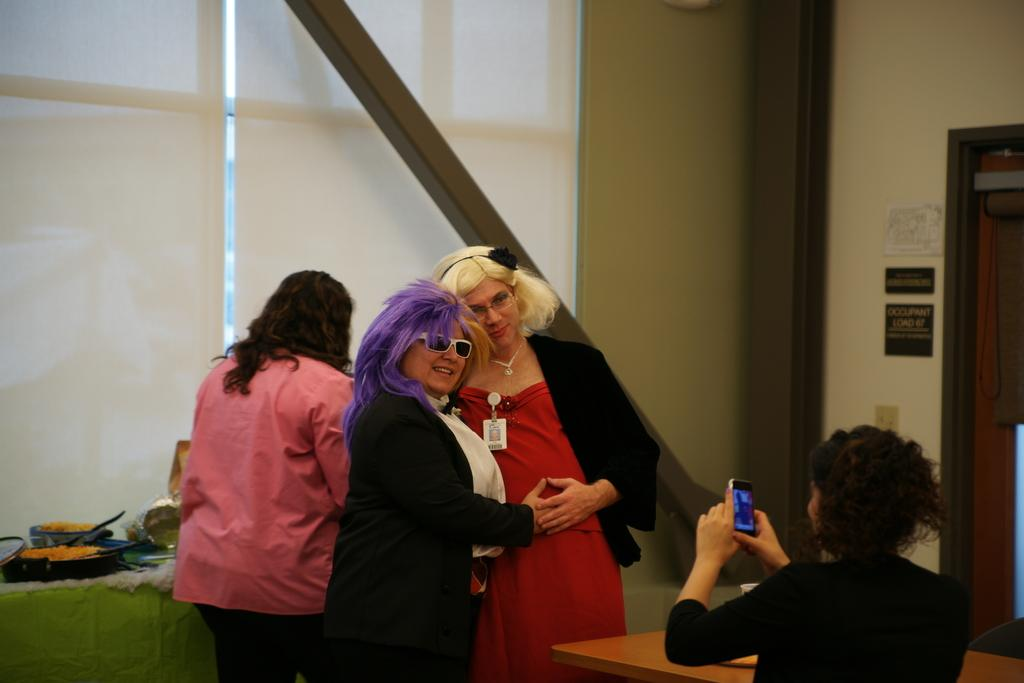What can be seen in the image? There are women standing in the image. Where are the women standing? The women are standing on the floor. What can be seen in the background of the image? There are cooking pans, doors, name plates, a switch board, walls, and an iron bar visible in the background. What color is the crayon being used by the women in the image? There is no crayon present in the image. What fact can be learned about the women's feelings towards each other in the image? The image does not provide any information about the women's feelings towards each other. 